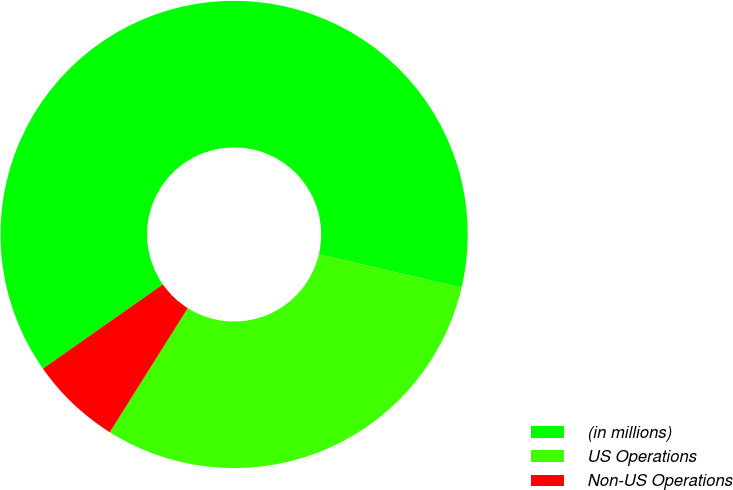<chart> <loc_0><loc_0><loc_500><loc_500><pie_chart><fcel>(in millions)<fcel>US Operations<fcel>Non-US Operations<nl><fcel>63.4%<fcel>30.27%<fcel>6.33%<nl></chart> 